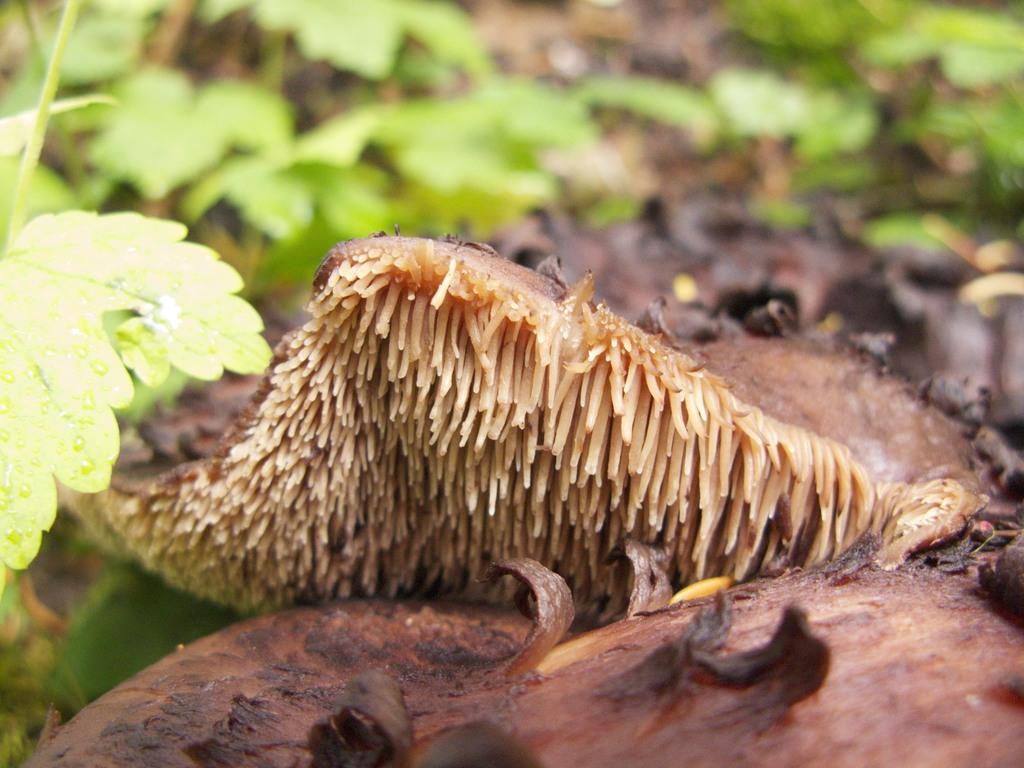What is the color of the objects in the image? The objects in the image are brown in color. What can be seen in the background of the image? There are plants with leaves in the background of the image. Is there a partner sleeping in the crib in the image? There is no crib or partner present in the image. What type of slip is being worn by the plants in the image? The plants in the image do not wear any clothing, including slips. 